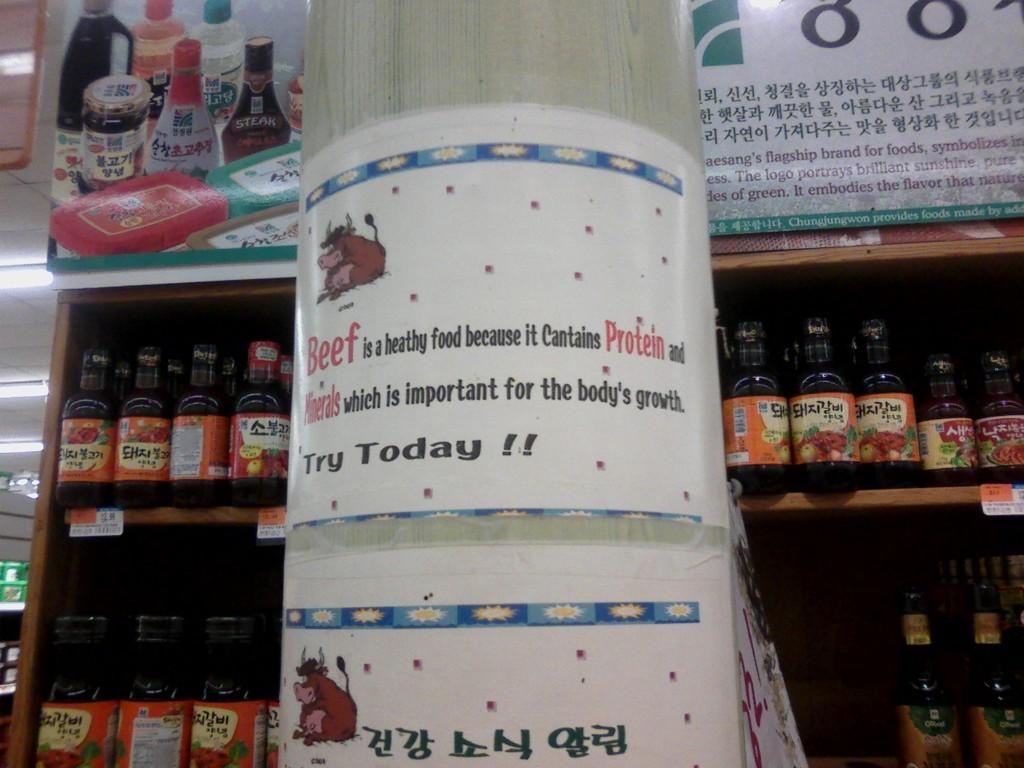According to the sign, what 2 important nutrients are found in beef?
Your answer should be compact. Protein and minerals. Is this a sporting event?
Ensure brevity in your answer.  No. 